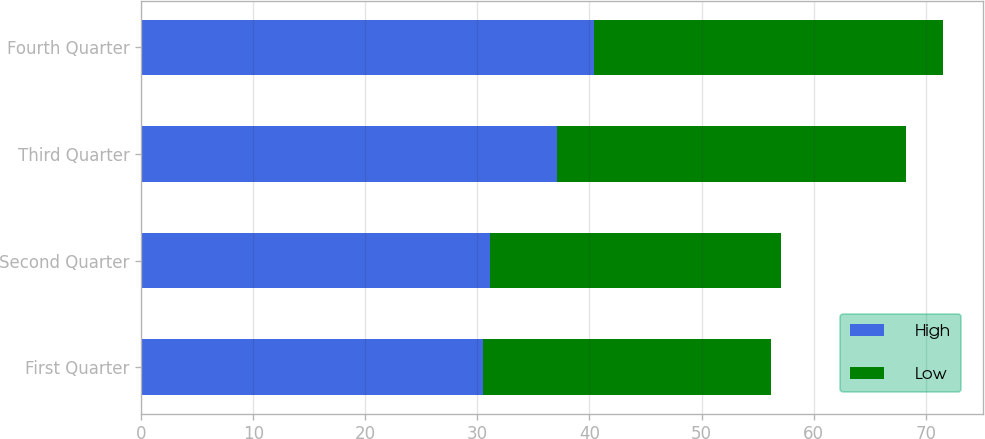Convert chart. <chart><loc_0><loc_0><loc_500><loc_500><stacked_bar_chart><ecel><fcel>First Quarter<fcel>Second Quarter<fcel>Third Quarter<fcel>Fourth Quarter<nl><fcel>High<fcel>30.48<fcel>31.15<fcel>37.1<fcel>40.41<nl><fcel>Low<fcel>25.74<fcel>25.95<fcel>31.17<fcel>31.11<nl></chart> 